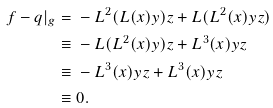<formula> <loc_0><loc_0><loc_500><loc_500>f - q | _ { g } = & \ - L ^ { 2 } ( L ( x ) y ) z + L ( L ^ { 2 } ( x ) y z ) \\ \equiv & \ - L ( L ^ { 2 } ( x ) y ) z + L ^ { 3 } ( x ) y z \\ \equiv & \ - L ^ { 3 } ( x ) y z + L ^ { 3 } ( x ) y z \\ \equiv & \ 0 .</formula> 